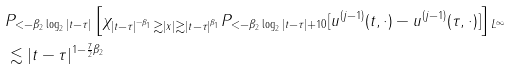Convert formula to latex. <formula><loc_0><loc_0><loc_500><loc_500>& \| P _ { < - \beta _ { 2 } \log _ { 2 } | t - \tau | } \left [ \chi _ { | t - \tau | ^ { - \beta _ { 1 } } \gtrsim | x | \gtrsim | t - \tau | ^ { \beta _ { 1 } } } P _ { < - \beta _ { 2 } \log _ { 2 } | t - \tau | + 1 0 } [ u ^ { ( j - 1 ) } ( t , \cdot ) - u ^ { ( j - 1 ) } ( \tau , \cdot ) ] \right ] \| _ { L ^ { \infty } } \\ & \lesssim | t - \tau | ^ { 1 - \frac { 7 } { 2 } \beta _ { 2 } }</formula> 